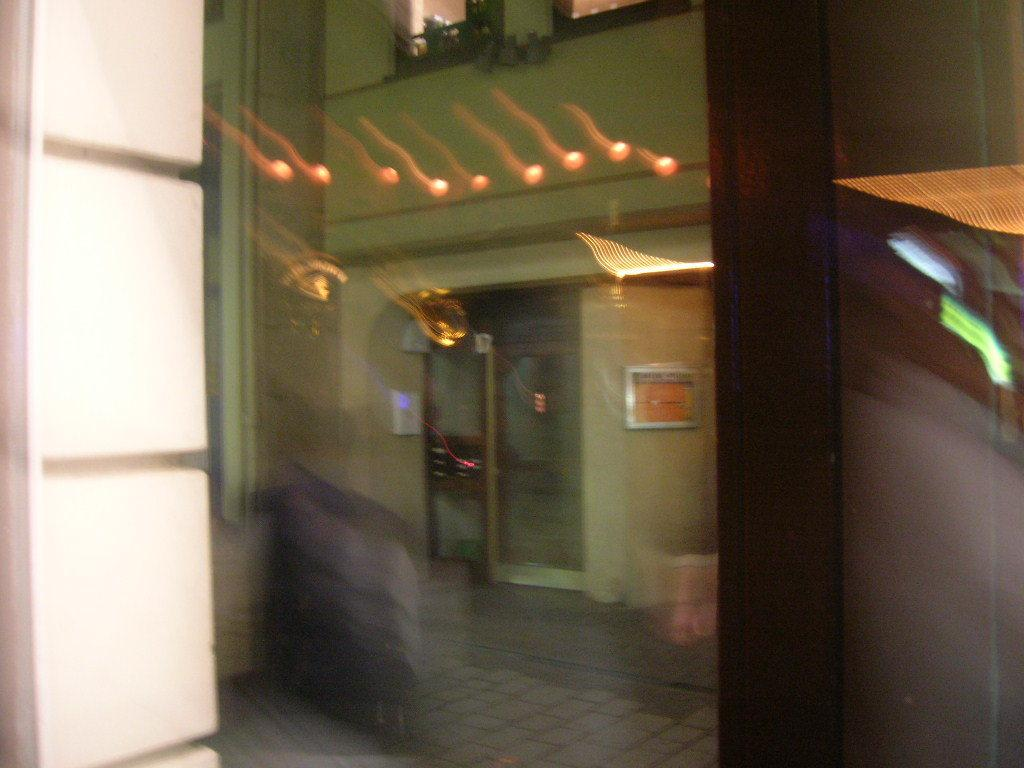What can be observed about the quality of the image? The image is blurry. Where was the image captured from? The image was captured from behind a window. What is the main subject of the image? There is a building in the image. Can you describe any additional features of the building? There is an object attached to the wall of the building on the right side. What type of spring is visible on the building in the image? There is no spring present in the image; it is a building with an object attached to the wall on the right side. 